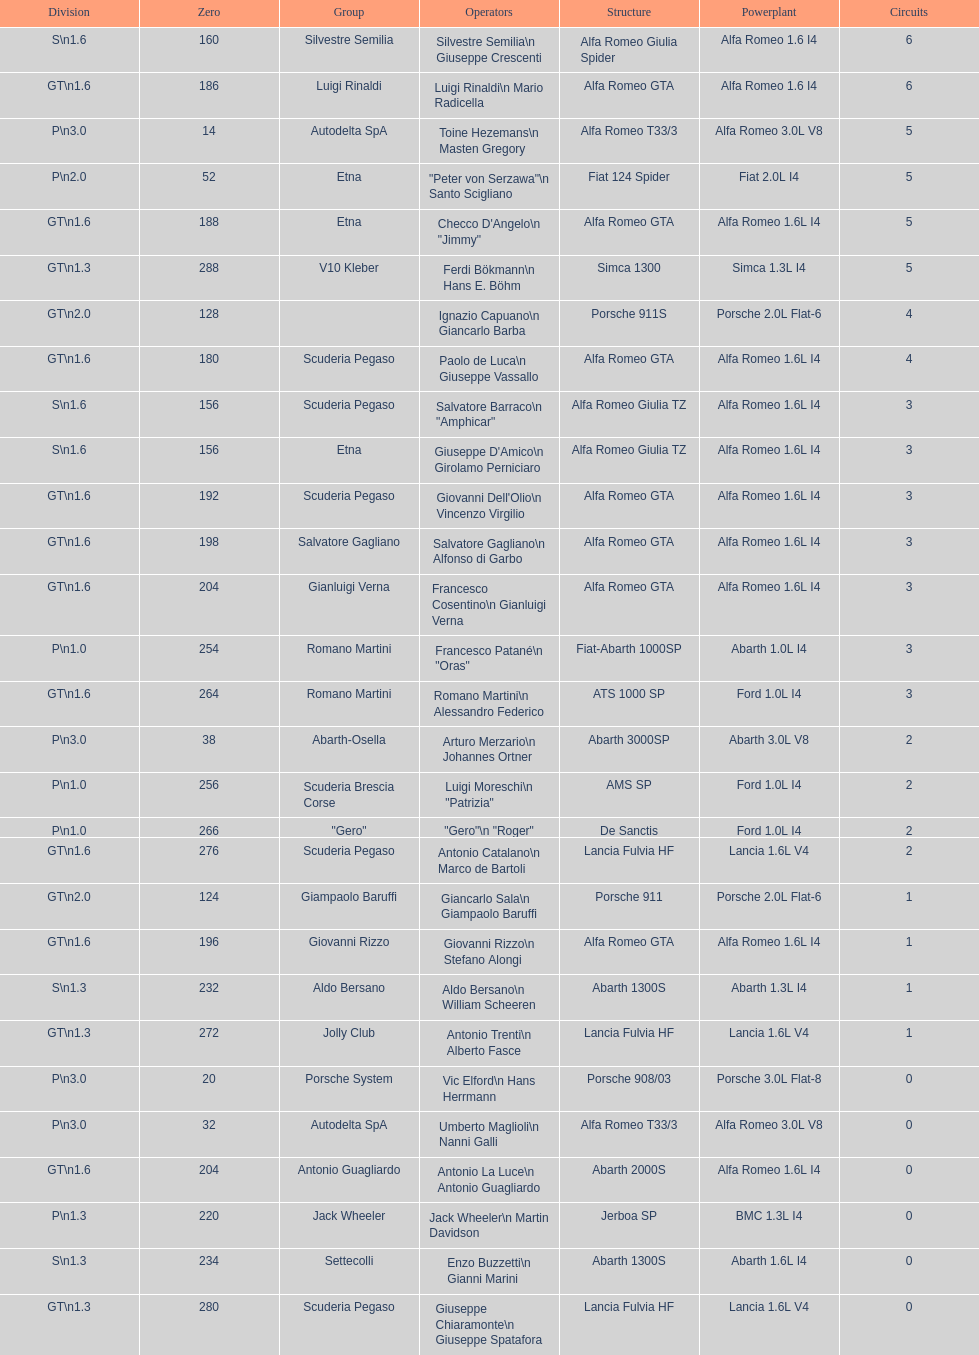His nickname is "jimmy," but what is his full name? Checco D'Angelo. 